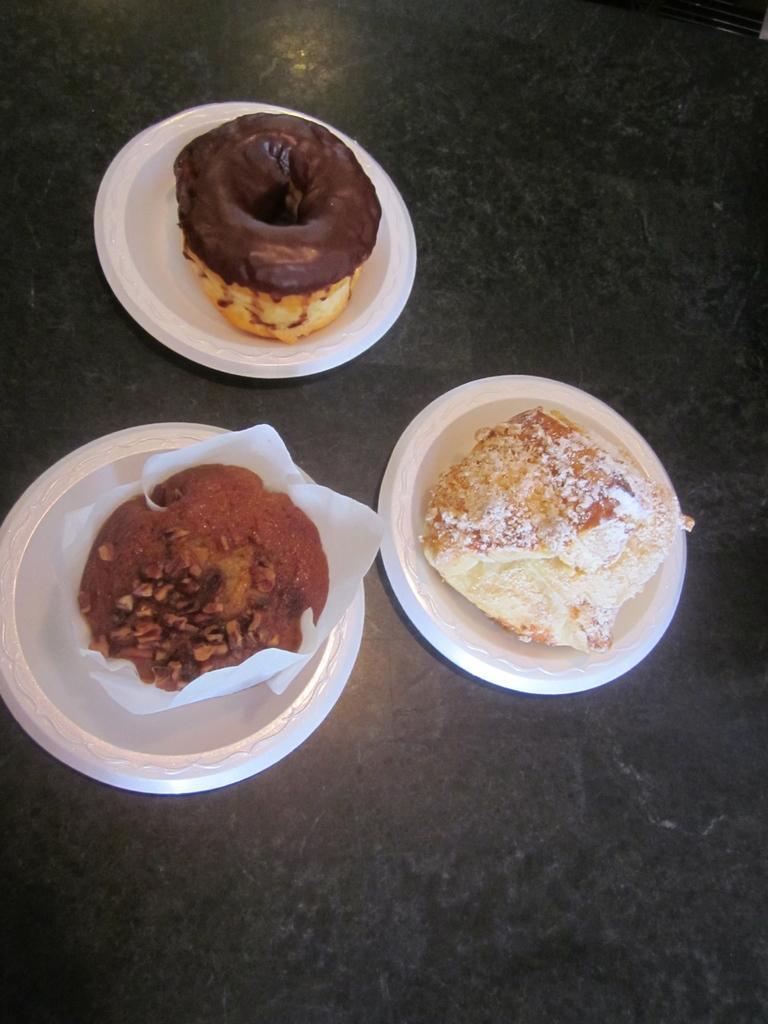Describe this image in one or two sentences. Here I can see three plates which consists of different food items. These plates are placed on the floor. 